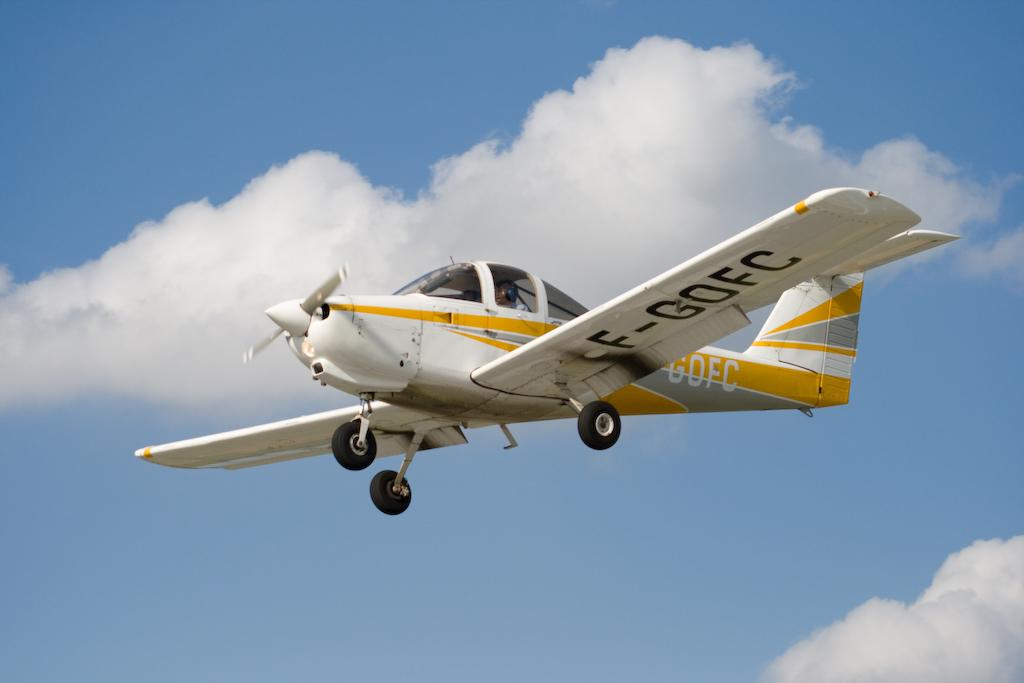<image>
Share a concise interpretation of the image provided. A plane labeled F-GOFC flies through the air 